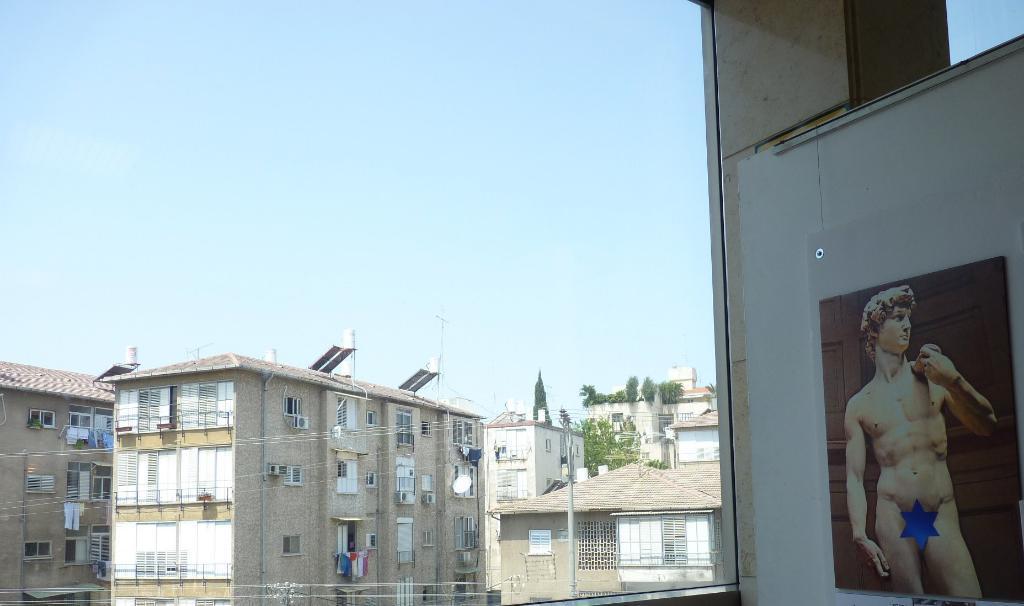Can you describe this image briefly? In this picture we can see some buildings, on the right side there is a wall, we can see a poster on the wall, there are some wires and a pole in the middle, in the background there are some plants, we can see the sky at the top of the picture. 